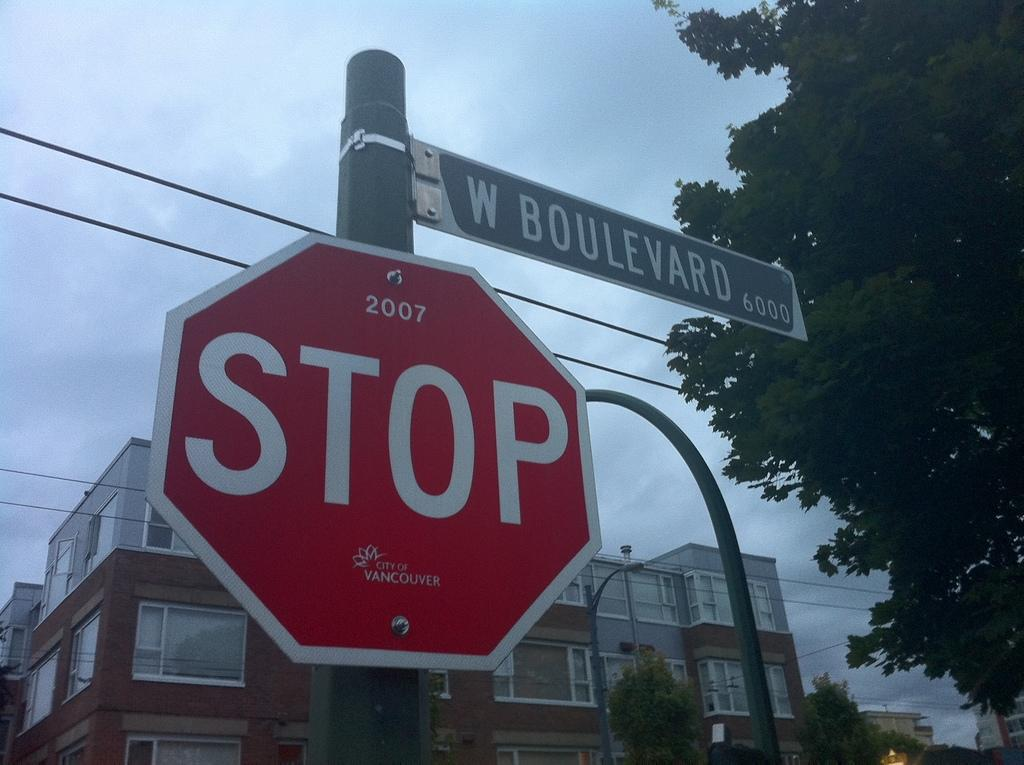<image>
Describe the image concisely. A red stop sign that says stop on it below a sign for W Boulevard 